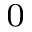Convert formula to latex. <formula><loc_0><loc_0><loc_500><loc_500>_ { 0 }</formula> 